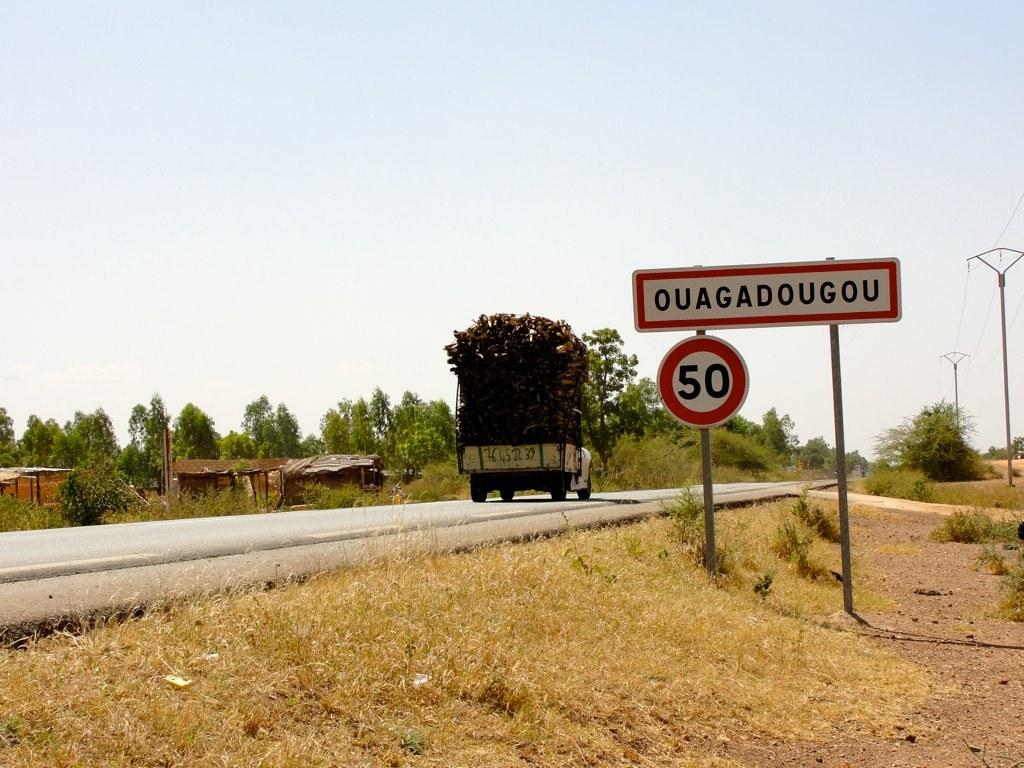<image>
Offer a succinct explanation of the picture presented. A truck travels along a country road past signs saying Ouagadougou and 50 